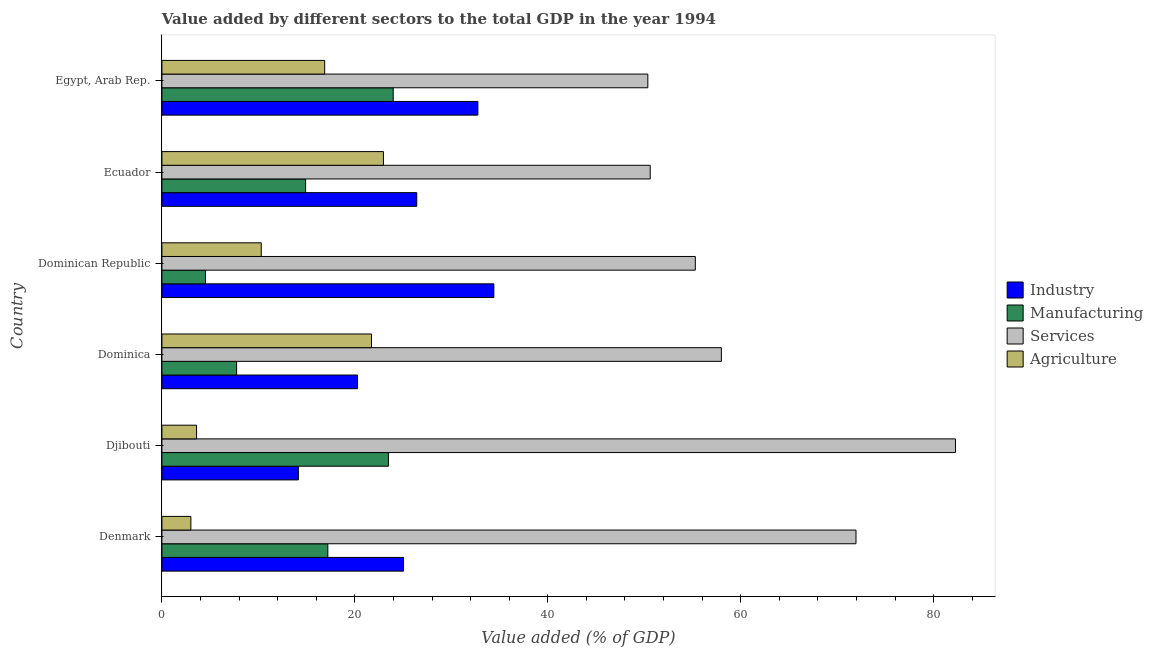How many different coloured bars are there?
Your response must be concise. 4. How many bars are there on the 2nd tick from the bottom?
Your answer should be very brief. 4. What is the label of the 2nd group of bars from the top?
Keep it short and to the point. Ecuador. What is the value added by manufacturing sector in Ecuador?
Your answer should be compact. 14.89. Across all countries, what is the maximum value added by industrial sector?
Keep it short and to the point. 34.41. Across all countries, what is the minimum value added by services sector?
Offer a terse response. 50.37. In which country was the value added by industrial sector maximum?
Give a very brief answer. Dominican Republic. In which country was the value added by services sector minimum?
Your response must be concise. Egypt, Arab Rep. What is the total value added by manufacturing sector in the graph?
Offer a very short reply. 91.81. What is the difference between the value added by services sector in Dominica and that in Ecuador?
Your answer should be very brief. 7.38. What is the difference between the value added by industrial sector in Ecuador and the value added by agricultural sector in Egypt, Arab Rep.?
Ensure brevity in your answer.  9.54. What is the average value added by agricultural sector per country?
Your response must be concise. 13.08. What is the difference between the value added by agricultural sector and value added by industrial sector in Denmark?
Keep it short and to the point. -22.05. In how many countries, is the value added by agricultural sector greater than 32 %?
Offer a very short reply. 0. What is the ratio of the value added by industrial sector in Ecuador to that in Egypt, Arab Rep.?
Offer a very short reply. 0.81. Is the value added by industrial sector in Djibouti less than that in Egypt, Arab Rep.?
Make the answer very short. Yes. Is the difference between the value added by industrial sector in Denmark and Djibouti greater than the difference between the value added by agricultural sector in Denmark and Djibouti?
Your answer should be very brief. Yes. What is the difference between the highest and the second highest value added by industrial sector?
Provide a short and direct response. 1.66. What is the difference between the highest and the lowest value added by services sector?
Offer a very short reply. 31.89. In how many countries, is the value added by services sector greater than the average value added by services sector taken over all countries?
Your answer should be very brief. 2. What does the 3rd bar from the top in Djibouti represents?
Provide a short and direct response. Manufacturing. What does the 2nd bar from the bottom in Denmark represents?
Your answer should be compact. Manufacturing. How many bars are there?
Offer a very short reply. 24. Are all the bars in the graph horizontal?
Offer a terse response. Yes. How many countries are there in the graph?
Give a very brief answer. 6. Are the values on the major ticks of X-axis written in scientific E-notation?
Make the answer very short. No. Does the graph contain grids?
Offer a very short reply. No. Where does the legend appear in the graph?
Offer a terse response. Center right. What is the title of the graph?
Offer a terse response. Value added by different sectors to the total GDP in the year 1994. Does "Other Minerals" appear as one of the legend labels in the graph?
Keep it short and to the point. No. What is the label or title of the X-axis?
Ensure brevity in your answer.  Value added (% of GDP). What is the label or title of the Y-axis?
Provide a succinct answer. Country. What is the Value added (% of GDP) in Industry in Denmark?
Your answer should be compact. 25.05. What is the Value added (% of GDP) in Manufacturing in Denmark?
Offer a very short reply. 17.2. What is the Value added (% of GDP) in Services in Denmark?
Offer a terse response. 71.95. What is the Value added (% of GDP) in Agriculture in Denmark?
Provide a succinct answer. 3. What is the Value added (% of GDP) in Industry in Djibouti?
Keep it short and to the point. 14.15. What is the Value added (% of GDP) of Manufacturing in Djibouti?
Offer a terse response. 23.48. What is the Value added (% of GDP) in Services in Djibouti?
Provide a succinct answer. 82.26. What is the Value added (% of GDP) of Agriculture in Djibouti?
Your response must be concise. 3.59. What is the Value added (% of GDP) in Industry in Dominica?
Your answer should be very brief. 20.28. What is the Value added (% of GDP) in Manufacturing in Dominica?
Offer a terse response. 7.74. What is the Value added (% of GDP) in Services in Dominica?
Ensure brevity in your answer.  57.99. What is the Value added (% of GDP) in Agriculture in Dominica?
Make the answer very short. 21.73. What is the Value added (% of GDP) of Industry in Dominican Republic?
Ensure brevity in your answer.  34.41. What is the Value added (% of GDP) in Manufacturing in Dominican Republic?
Your response must be concise. 4.51. What is the Value added (% of GDP) of Services in Dominican Republic?
Provide a succinct answer. 55.29. What is the Value added (% of GDP) in Agriculture in Dominican Republic?
Make the answer very short. 10.3. What is the Value added (% of GDP) in Industry in Ecuador?
Make the answer very short. 26.42. What is the Value added (% of GDP) of Manufacturing in Ecuador?
Your answer should be compact. 14.89. What is the Value added (% of GDP) of Services in Ecuador?
Your answer should be very brief. 50.62. What is the Value added (% of GDP) of Agriculture in Ecuador?
Offer a very short reply. 22.97. What is the Value added (% of GDP) in Industry in Egypt, Arab Rep.?
Give a very brief answer. 32.76. What is the Value added (% of GDP) of Manufacturing in Egypt, Arab Rep.?
Make the answer very short. 23.98. What is the Value added (% of GDP) of Services in Egypt, Arab Rep.?
Offer a terse response. 50.37. What is the Value added (% of GDP) in Agriculture in Egypt, Arab Rep.?
Offer a very short reply. 16.87. Across all countries, what is the maximum Value added (% of GDP) in Industry?
Make the answer very short. 34.41. Across all countries, what is the maximum Value added (% of GDP) in Manufacturing?
Offer a very short reply. 23.98. Across all countries, what is the maximum Value added (% of GDP) of Services?
Provide a succinct answer. 82.26. Across all countries, what is the maximum Value added (% of GDP) in Agriculture?
Keep it short and to the point. 22.97. Across all countries, what is the minimum Value added (% of GDP) in Industry?
Provide a short and direct response. 14.15. Across all countries, what is the minimum Value added (% of GDP) of Manufacturing?
Make the answer very short. 4.51. Across all countries, what is the minimum Value added (% of GDP) of Services?
Your response must be concise. 50.37. Across all countries, what is the minimum Value added (% of GDP) in Agriculture?
Provide a short and direct response. 3. What is the total Value added (% of GDP) in Industry in the graph?
Keep it short and to the point. 153.06. What is the total Value added (% of GDP) of Manufacturing in the graph?
Offer a terse response. 91.81. What is the total Value added (% of GDP) of Services in the graph?
Your response must be concise. 368.48. What is the total Value added (% of GDP) in Agriculture in the graph?
Make the answer very short. 78.46. What is the difference between the Value added (% of GDP) in Industry in Denmark and that in Djibouti?
Provide a short and direct response. 10.9. What is the difference between the Value added (% of GDP) in Manufacturing in Denmark and that in Djibouti?
Provide a short and direct response. -6.28. What is the difference between the Value added (% of GDP) in Services in Denmark and that in Djibouti?
Provide a short and direct response. -10.31. What is the difference between the Value added (% of GDP) of Agriculture in Denmark and that in Djibouti?
Your answer should be very brief. -0.59. What is the difference between the Value added (% of GDP) of Industry in Denmark and that in Dominica?
Give a very brief answer. 4.77. What is the difference between the Value added (% of GDP) in Manufacturing in Denmark and that in Dominica?
Your answer should be very brief. 9.46. What is the difference between the Value added (% of GDP) of Services in Denmark and that in Dominica?
Provide a short and direct response. 13.96. What is the difference between the Value added (% of GDP) in Agriculture in Denmark and that in Dominica?
Your response must be concise. -18.72. What is the difference between the Value added (% of GDP) in Industry in Denmark and that in Dominican Republic?
Offer a very short reply. -9.36. What is the difference between the Value added (% of GDP) of Manufacturing in Denmark and that in Dominican Republic?
Offer a very short reply. 12.69. What is the difference between the Value added (% of GDP) in Services in Denmark and that in Dominican Republic?
Provide a short and direct response. 16.66. What is the difference between the Value added (% of GDP) of Agriculture in Denmark and that in Dominican Republic?
Offer a terse response. -7.29. What is the difference between the Value added (% of GDP) in Industry in Denmark and that in Ecuador?
Ensure brevity in your answer.  -1.37. What is the difference between the Value added (% of GDP) of Manufacturing in Denmark and that in Ecuador?
Ensure brevity in your answer.  2.31. What is the difference between the Value added (% of GDP) in Services in Denmark and that in Ecuador?
Make the answer very short. 21.33. What is the difference between the Value added (% of GDP) of Agriculture in Denmark and that in Ecuador?
Your answer should be very brief. -19.96. What is the difference between the Value added (% of GDP) in Industry in Denmark and that in Egypt, Arab Rep.?
Your answer should be compact. -7.71. What is the difference between the Value added (% of GDP) in Manufacturing in Denmark and that in Egypt, Arab Rep.?
Offer a very short reply. -6.78. What is the difference between the Value added (% of GDP) of Services in Denmark and that in Egypt, Arab Rep.?
Offer a very short reply. 21.58. What is the difference between the Value added (% of GDP) in Agriculture in Denmark and that in Egypt, Arab Rep.?
Provide a short and direct response. -13.87. What is the difference between the Value added (% of GDP) of Industry in Djibouti and that in Dominica?
Ensure brevity in your answer.  -6.13. What is the difference between the Value added (% of GDP) of Manufacturing in Djibouti and that in Dominica?
Give a very brief answer. 15.74. What is the difference between the Value added (% of GDP) of Services in Djibouti and that in Dominica?
Your answer should be compact. 24.27. What is the difference between the Value added (% of GDP) in Agriculture in Djibouti and that in Dominica?
Make the answer very short. -18.13. What is the difference between the Value added (% of GDP) of Industry in Djibouti and that in Dominican Republic?
Offer a terse response. -20.26. What is the difference between the Value added (% of GDP) of Manufacturing in Djibouti and that in Dominican Republic?
Make the answer very short. 18.97. What is the difference between the Value added (% of GDP) of Services in Djibouti and that in Dominican Republic?
Provide a succinct answer. 26.97. What is the difference between the Value added (% of GDP) of Agriculture in Djibouti and that in Dominican Republic?
Provide a short and direct response. -6.7. What is the difference between the Value added (% of GDP) in Industry in Djibouti and that in Ecuador?
Provide a short and direct response. -12.27. What is the difference between the Value added (% of GDP) in Manufacturing in Djibouti and that in Ecuador?
Ensure brevity in your answer.  8.59. What is the difference between the Value added (% of GDP) of Services in Djibouti and that in Ecuador?
Provide a succinct answer. 31.64. What is the difference between the Value added (% of GDP) in Agriculture in Djibouti and that in Ecuador?
Your answer should be very brief. -19.37. What is the difference between the Value added (% of GDP) in Industry in Djibouti and that in Egypt, Arab Rep.?
Your answer should be very brief. -18.61. What is the difference between the Value added (% of GDP) of Manufacturing in Djibouti and that in Egypt, Arab Rep.?
Make the answer very short. -0.5. What is the difference between the Value added (% of GDP) in Services in Djibouti and that in Egypt, Arab Rep.?
Ensure brevity in your answer.  31.89. What is the difference between the Value added (% of GDP) of Agriculture in Djibouti and that in Egypt, Arab Rep.?
Provide a succinct answer. -13.28. What is the difference between the Value added (% of GDP) of Industry in Dominica and that in Dominican Republic?
Give a very brief answer. -14.13. What is the difference between the Value added (% of GDP) in Manufacturing in Dominica and that in Dominican Republic?
Provide a short and direct response. 3.23. What is the difference between the Value added (% of GDP) in Services in Dominica and that in Dominican Republic?
Make the answer very short. 2.7. What is the difference between the Value added (% of GDP) of Agriculture in Dominica and that in Dominican Republic?
Give a very brief answer. 11.43. What is the difference between the Value added (% of GDP) in Industry in Dominica and that in Ecuador?
Make the answer very short. -6.14. What is the difference between the Value added (% of GDP) of Manufacturing in Dominica and that in Ecuador?
Offer a terse response. -7.15. What is the difference between the Value added (% of GDP) in Services in Dominica and that in Ecuador?
Your response must be concise. 7.38. What is the difference between the Value added (% of GDP) of Agriculture in Dominica and that in Ecuador?
Offer a very short reply. -1.24. What is the difference between the Value added (% of GDP) in Industry in Dominica and that in Egypt, Arab Rep.?
Offer a terse response. -12.47. What is the difference between the Value added (% of GDP) of Manufacturing in Dominica and that in Egypt, Arab Rep.?
Your answer should be very brief. -16.23. What is the difference between the Value added (% of GDP) in Services in Dominica and that in Egypt, Arab Rep.?
Provide a succinct answer. 7.62. What is the difference between the Value added (% of GDP) of Agriculture in Dominica and that in Egypt, Arab Rep.?
Your response must be concise. 4.85. What is the difference between the Value added (% of GDP) in Industry in Dominican Republic and that in Ecuador?
Make the answer very short. 7.99. What is the difference between the Value added (% of GDP) in Manufacturing in Dominican Republic and that in Ecuador?
Give a very brief answer. -10.38. What is the difference between the Value added (% of GDP) in Services in Dominican Republic and that in Ecuador?
Offer a terse response. 4.68. What is the difference between the Value added (% of GDP) in Agriculture in Dominican Republic and that in Ecuador?
Offer a very short reply. -12.67. What is the difference between the Value added (% of GDP) of Industry in Dominican Republic and that in Egypt, Arab Rep.?
Give a very brief answer. 1.66. What is the difference between the Value added (% of GDP) in Manufacturing in Dominican Republic and that in Egypt, Arab Rep.?
Ensure brevity in your answer.  -19.46. What is the difference between the Value added (% of GDP) in Services in Dominican Republic and that in Egypt, Arab Rep.?
Provide a short and direct response. 4.92. What is the difference between the Value added (% of GDP) in Agriculture in Dominican Republic and that in Egypt, Arab Rep.?
Your answer should be very brief. -6.58. What is the difference between the Value added (% of GDP) in Industry in Ecuador and that in Egypt, Arab Rep.?
Provide a succinct answer. -6.34. What is the difference between the Value added (% of GDP) in Manufacturing in Ecuador and that in Egypt, Arab Rep.?
Your answer should be compact. -9.08. What is the difference between the Value added (% of GDP) of Services in Ecuador and that in Egypt, Arab Rep.?
Offer a very short reply. 0.25. What is the difference between the Value added (% of GDP) in Agriculture in Ecuador and that in Egypt, Arab Rep.?
Give a very brief answer. 6.09. What is the difference between the Value added (% of GDP) of Industry in Denmark and the Value added (% of GDP) of Manufacturing in Djibouti?
Provide a succinct answer. 1.57. What is the difference between the Value added (% of GDP) in Industry in Denmark and the Value added (% of GDP) in Services in Djibouti?
Give a very brief answer. -57.21. What is the difference between the Value added (% of GDP) in Industry in Denmark and the Value added (% of GDP) in Agriculture in Djibouti?
Keep it short and to the point. 21.45. What is the difference between the Value added (% of GDP) of Manufacturing in Denmark and the Value added (% of GDP) of Services in Djibouti?
Offer a very short reply. -65.06. What is the difference between the Value added (% of GDP) in Manufacturing in Denmark and the Value added (% of GDP) in Agriculture in Djibouti?
Your answer should be compact. 13.61. What is the difference between the Value added (% of GDP) in Services in Denmark and the Value added (% of GDP) in Agriculture in Djibouti?
Provide a short and direct response. 68.35. What is the difference between the Value added (% of GDP) of Industry in Denmark and the Value added (% of GDP) of Manufacturing in Dominica?
Provide a succinct answer. 17.3. What is the difference between the Value added (% of GDP) of Industry in Denmark and the Value added (% of GDP) of Services in Dominica?
Keep it short and to the point. -32.94. What is the difference between the Value added (% of GDP) of Industry in Denmark and the Value added (% of GDP) of Agriculture in Dominica?
Offer a terse response. 3.32. What is the difference between the Value added (% of GDP) of Manufacturing in Denmark and the Value added (% of GDP) of Services in Dominica?
Ensure brevity in your answer.  -40.79. What is the difference between the Value added (% of GDP) of Manufacturing in Denmark and the Value added (% of GDP) of Agriculture in Dominica?
Provide a short and direct response. -4.53. What is the difference between the Value added (% of GDP) in Services in Denmark and the Value added (% of GDP) in Agriculture in Dominica?
Provide a succinct answer. 50.22. What is the difference between the Value added (% of GDP) of Industry in Denmark and the Value added (% of GDP) of Manufacturing in Dominican Republic?
Provide a short and direct response. 20.53. What is the difference between the Value added (% of GDP) in Industry in Denmark and the Value added (% of GDP) in Services in Dominican Republic?
Keep it short and to the point. -30.24. What is the difference between the Value added (% of GDP) in Industry in Denmark and the Value added (% of GDP) in Agriculture in Dominican Republic?
Your response must be concise. 14.75. What is the difference between the Value added (% of GDP) of Manufacturing in Denmark and the Value added (% of GDP) of Services in Dominican Republic?
Make the answer very short. -38.09. What is the difference between the Value added (% of GDP) in Manufacturing in Denmark and the Value added (% of GDP) in Agriculture in Dominican Republic?
Provide a succinct answer. 6.9. What is the difference between the Value added (% of GDP) in Services in Denmark and the Value added (% of GDP) in Agriculture in Dominican Republic?
Provide a succinct answer. 61.65. What is the difference between the Value added (% of GDP) in Industry in Denmark and the Value added (% of GDP) in Manufacturing in Ecuador?
Provide a succinct answer. 10.15. What is the difference between the Value added (% of GDP) in Industry in Denmark and the Value added (% of GDP) in Services in Ecuador?
Keep it short and to the point. -25.57. What is the difference between the Value added (% of GDP) of Industry in Denmark and the Value added (% of GDP) of Agriculture in Ecuador?
Offer a terse response. 2.08. What is the difference between the Value added (% of GDP) in Manufacturing in Denmark and the Value added (% of GDP) in Services in Ecuador?
Your answer should be very brief. -33.42. What is the difference between the Value added (% of GDP) in Manufacturing in Denmark and the Value added (% of GDP) in Agriculture in Ecuador?
Your response must be concise. -5.77. What is the difference between the Value added (% of GDP) of Services in Denmark and the Value added (% of GDP) of Agriculture in Ecuador?
Give a very brief answer. 48.98. What is the difference between the Value added (% of GDP) of Industry in Denmark and the Value added (% of GDP) of Manufacturing in Egypt, Arab Rep.?
Your answer should be very brief. 1.07. What is the difference between the Value added (% of GDP) in Industry in Denmark and the Value added (% of GDP) in Services in Egypt, Arab Rep.?
Ensure brevity in your answer.  -25.32. What is the difference between the Value added (% of GDP) in Industry in Denmark and the Value added (% of GDP) in Agriculture in Egypt, Arab Rep.?
Keep it short and to the point. 8.17. What is the difference between the Value added (% of GDP) of Manufacturing in Denmark and the Value added (% of GDP) of Services in Egypt, Arab Rep.?
Ensure brevity in your answer.  -33.17. What is the difference between the Value added (% of GDP) of Manufacturing in Denmark and the Value added (% of GDP) of Agriculture in Egypt, Arab Rep.?
Your answer should be very brief. 0.33. What is the difference between the Value added (% of GDP) of Services in Denmark and the Value added (% of GDP) of Agriculture in Egypt, Arab Rep.?
Offer a very short reply. 55.07. What is the difference between the Value added (% of GDP) of Industry in Djibouti and the Value added (% of GDP) of Manufacturing in Dominica?
Provide a succinct answer. 6.4. What is the difference between the Value added (% of GDP) in Industry in Djibouti and the Value added (% of GDP) in Services in Dominica?
Provide a succinct answer. -43.85. What is the difference between the Value added (% of GDP) of Industry in Djibouti and the Value added (% of GDP) of Agriculture in Dominica?
Provide a succinct answer. -7.58. What is the difference between the Value added (% of GDP) of Manufacturing in Djibouti and the Value added (% of GDP) of Services in Dominica?
Give a very brief answer. -34.51. What is the difference between the Value added (% of GDP) in Manufacturing in Djibouti and the Value added (% of GDP) in Agriculture in Dominica?
Ensure brevity in your answer.  1.75. What is the difference between the Value added (% of GDP) of Services in Djibouti and the Value added (% of GDP) of Agriculture in Dominica?
Offer a very short reply. 60.53. What is the difference between the Value added (% of GDP) in Industry in Djibouti and the Value added (% of GDP) in Manufacturing in Dominican Republic?
Offer a terse response. 9.63. What is the difference between the Value added (% of GDP) of Industry in Djibouti and the Value added (% of GDP) of Services in Dominican Republic?
Give a very brief answer. -41.15. What is the difference between the Value added (% of GDP) in Industry in Djibouti and the Value added (% of GDP) in Agriculture in Dominican Republic?
Your answer should be compact. 3.85. What is the difference between the Value added (% of GDP) of Manufacturing in Djibouti and the Value added (% of GDP) of Services in Dominican Republic?
Give a very brief answer. -31.81. What is the difference between the Value added (% of GDP) in Manufacturing in Djibouti and the Value added (% of GDP) in Agriculture in Dominican Republic?
Your response must be concise. 13.18. What is the difference between the Value added (% of GDP) in Services in Djibouti and the Value added (% of GDP) in Agriculture in Dominican Republic?
Keep it short and to the point. 71.96. What is the difference between the Value added (% of GDP) in Industry in Djibouti and the Value added (% of GDP) in Manufacturing in Ecuador?
Provide a succinct answer. -0.75. What is the difference between the Value added (% of GDP) of Industry in Djibouti and the Value added (% of GDP) of Services in Ecuador?
Provide a short and direct response. -36.47. What is the difference between the Value added (% of GDP) in Industry in Djibouti and the Value added (% of GDP) in Agriculture in Ecuador?
Your response must be concise. -8.82. What is the difference between the Value added (% of GDP) of Manufacturing in Djibouti and the Value added (% of GDP) of Services in Ecuador?
Provide a short and direct response. -27.14. What is the difference between the Value added (% of GDP) of Manufacturing in Djibouti and the Value added (% of GDP) of Agriculture in Ecuador?
Keep it short and to the point. 0.51. What is the difference between the Value added (% of GDP) of Services in Djibouti and the Value added (% of GDP) of Agriculture in Ecuador?
Ensure brevity in your answer.  59.29. What is the difference between the Value added (% of GDP) in Industry in Djibouti and the Value added (% of GDP) in Manufacturing in Egypt, Arab Rep.?
Your response must be concise. -9.83. What is the difference between the Value added (% of GDP) in Industry in Djibouti and the Value added (% of GDP) in Services in Egypt, Arab Rep.?
Your response must be concise. -36.22. What is the difference between the Value added (% of GDP) in Industry in Djibouti and the Value added (% of GDP) in Agriculture in Egypt, Arab Rep.?
Provide a short and direct response. -2.73. What is the difference between the Value added (% of GDP) of Manufacturing in Djibouti and the Value added (% of GDP) of Services in Egypt, Arab Rep.?
Provide a short and direct response. -26.89. What is the difference between the Value added (% of GDP) in Manufacturing in Djibouti and the Value added (% of GDP) in Agriculture in Egypt, Arab Rep.?
Ensure brevity in your answer.  6.61. What is the difference between the Value added (% of GDP) of Services in Djibouti and the Value added (% of GDP) of Agriculture in Egypt, Arab Rep.?
Offer a very short reply. 65.39. What is the difference between the Value added (% of GDP) of Industry in Dominica and the Value added (% of GDP) of Manufacturing in Dominican Republic?
Keep it short and to the point. 15.77. What is the difference between the Value added (% of GDP) of Industry in Dominica and the Value added (% of GDP) of Services in Dominican Republic?
Offer a terse response. -35.01. What is the difference between the Value added (% of GDP) in Industry in Dominica and the Value added (% of GDP) in Agriculture in Dominican Republic?
Provide a short and direct response. 9.98. What is the difference between the Value added (% of GDP) of Manufacturing in Dominica and the Value added (% of GDP) of Services in Dominican Republic?
Your response must be concise. -47.55. What is the difference between the Value added (% of GDP) in Manufacturing in Dominica and the Value added (% of GDP) in Agriculture in Dominican Republic?
Provide a short and direct response. -2.55. What is the difference between the Value added (% of GDP) in Services in Dominica and the Value added (% of GDP) in Agriculture in Dominican Republic?
Give a very brief answer. 47.7. What is the difference between the Value added (% of GDP) in Industry in Dominica and the Value added (% of GDP) in Manufacturing in Ecuador?
Offer a very short reply. 5.39. What is the difference between the Value added (% of GDP) of Industry in Dominica and the Value added (% of GDP) of Services in Ecuador?
Provide a succinct answer. -30.33. What is the difference between the Value added (% of GDP) in Industry in Dominica and the Value added (% of GDP) in Agriculture in Ecuador?
Provide a short and direct response. -2.68. What is the difference between the Value added (% of GDP) of Manufacturing in Dominica and the Value added (% of GDP) of Services in Ecuador?
Offer a terse response. -42.87. What is the difference between the Value added (% of GDP) in Manufacturing in Dominica and the Value added (% of GDP) in Agriculture in Ecuador?
Your answer should be very brief. -15.22. What is the difference between the Value added (% of GDP) in Services in Dominica and the Value added (% of GDP) in Agriculture in Ecuador?
Keep it short and to the point. 35.03. What is the difference between the Value added (% of GDP) in Industry in Dominica and the Value added (% of GDP) in Manufacturing in Egypt, Arab Rep.?
Make the answer very short. -3.7. What is the difference between the Value added (% of GDP) of Industry in Dominica and the Value added (% of GDP) of Services in Egypt, Arab Rep.?
Keep it short and to the point. -30.09. What is the difference between the Value added (% of GDP) in Industry in Dominica and the Value added (% of GDP) in Agriculture in Egypt, Arab Rep.?
Offer a very short reply. 3.41. What is the difference between the Value added (% of GDP) of Manufacturing in Dominica and the Value added (% of GDP) of Services in Egypt, Arab Rep.?
Ensure brevity in your answer.  -42.63. What is the difference between the Value added (% of GDP) of Manufacturing in Dominica and the Value added (% of GDP) of Agriculture in Egypt, Arab Rep.?
Your answer should be compact. -9.13. What is the difference between the Value added (% of GDP) of Services in Dominica and the Value added (% of GDP) of Agriculture in Egypt, Arab Rep.?
Your answer should be compact. 41.12. What is the difference between the Value added (% of GDP) in Industry in Dominican Republic and the Value added (% of GDP) in Manufacturing in Ecuador?
Ensure brevity in your answer.  19.52. What is the difference between the Value added (% of GDP) in Industry in Dominican Republic and the Value added (% of GDP) in Services in Ecuador?
Provide a succinct answer. -16.21. What is the difference between the Value added (% of GDP) in Industry in Dominican Republic and the Value added (% of GDP) in Agriculture in Ecuador?
Provide a succinct answer. 11.44. What is the difference between the Value added (% of GDP) of Manufacturing in Dominican Republic and the Value added (% of GDP) of Services in Ecuador?
Offer a very short reply. -46.1. What is the difference between the Value added (% of GDP) of Manufacturing in Dominican Republic and the Value added (% of GDP) of Agriculture in Ecuador?
Your answer should be very brief. -18.45. What is the difference between the Value added (% of GDP) in Services in Dominican Republic and the Value added (% of GDP) in Agriculture in Ecuador?
Your answer should be compact. 32.33. What is the difference between the Value added (% of GDP) of Industry in Dominican Republic and the Value added (% of GDP) of Manufacturing in Egypt, Arab Rep.?
Your response must be concise. 10.43. What is the difference between the Value added (% of GDP) in Industry in Dominican Republic and the Value added (% of GDP) in Services in Egypt, Arab Rep.?
Provide a short and direct response. -15.96. What is the difference between the Value added (% of GDP) of Industry in Dominican Republic and the Value added (% of GDP) of Agriculture in Egypt, Arab Rep.?
Offer a terse response. 17.54. What is the difference between the Value added (% of GDP) of Manufacturing in Dominican Republic and the Value added (% of GDP) of Services in Egypt, Arab Rep.?
Your answer should be compact. -45.86. What is the difference between the Value added (% of GDP) in Manufacturing in Dominican Republic and the Value added (% of GDP) in Agriculture in Egypt, Arab Rep.?
Your answer should be very brief. -12.36. What is the difference between the Value added (% of GDP) in Services in Dominican Republic and the Value added (% of GDP) in Agriculture in Egypt, Arab Rep.?
Offer a terse response. 38.42. What is the difference between the Value added (% of GDP) of Industry in Ecuador and the Value added (% of GDP) of Manufacturing in Egypt, Arab Rep.?
Your answer should be compact. 2.44. What is the difference between the Value added (% of GDP) of Industry in Ecuador and the Value added (% of GDP) of Services in Egypt, Arab Rep.?
Ensure brevity in your answer.  -23.95. What is the difference between the Value added (% of GDP) in Industry in Ecuador and the Value added (% of GDP) in Agriculture in Egypt, Arab Rep.?
Your response must be concise. 9.54. What is the difference between the Value added (% of GDP) in Manufacturing in Ecuador and the Value added (% of GDP) in Services in Egypt, Arab Rep.?
Ensure brevity in your answer.  -35.48. What is the difference between the Value added (% of GDP) of Manufacturing in Ecuador and the Value added (% of GDP) of Agriculture in Egypt, Arab Rep.?
Give a very brief answer. -1.98. What is the difference between the Value added (% of GDP) of Services in Ecuador and the Value added (% of GDP) of Agriculture in Egypt, Arab Rep.?
Offer a terse response. 33.74. What is the average Value added (% of GDP) of Industry per country?
Offer a very short reply. 25.51. What is the average Value added (% of GDP) in Manufacturing per country?
Offer a terse response. 15.3. What is the average Value added (% of GDP) in Services per country?
Make the answer very short. 61.41. What is the average Value added (% of GDP) in Agriculture per country?
Ensure brevity in your answer.  13.08. What is the difference between the Value added (% of GDP) of Industry and Value added (% of GDP) of Manufacturing in Denmark?
Offer a very short reply. 7.85. What is the difference between the Value added (% of GDP) in Industry and Value added (% of GDP) in Services in Denmark?
Your answer should be very brief. -46.9. What is the difference between the Value added (% of GDP) in Industry and Value added (% of GDP) in Agriculture in Denmark?
Give a very brief answer. 22.05. What is the difference between the Value added (% of GDP) in Manufacturing and Value added (% of GDP) in Services in Denmark?
Offer a very short reply. -54.75. What is the difference between the Value added (% of GDP) of Manufacturing and Value added (% of GDP) of Agriculture in Denmark?
Provide a succinct answer. 14.2. What is the difference between the Value added (% of GDP) in Services and Value added (% of GDP) in Agriculture in Denmark?
Give a very brief answer. 68.95. What is the difference between the Value added (% of GDP) in Industry and Value added (% of GDP) in Manufacturing in Djibouti?
Keep it short and to the point. -9.33. What is the difference between the Value added (% of GDP) in Industry and Value added (% of GDP) in Services in Djibouti?
Ensure brevity in your answer.  -68.11. What is the difference between the Value added (% of GDP) of Industry and Value added (% of GDP) of Agriculture in Djibouti?
Ensure brevity in your answer.  10.55. What is the difference between the Value added (% of GDP) of Manufacturing and Value added (% of GDP) of Services in Djibouti?
Your answer should be very brief. -58.78. What is the difference between the Value added (% of GDP) of Manufacturing and Value added (% of GDP) of Agriculture in Djibouti?
Your response must be concise. 19.89. What is the difference between the Value added (% of GDP) in Services and Value added (% of GDP) in Agriculture in Djibouti?
Provide a succinct answer. 78.67. What is the difference between the Value added (% of GDP) of Industry and Value added (% of GDP) of Manufacturing in Dominica?
Keep it short and to the point. 12.54. What is the difference between the Value added (% of GDP) in Industry and Value added (% of GDP) in Services in Dominica?
Make the answer very short. -37.71. What is the difference between the Value added (% of GDP) in Industry and Value added (% of GDP) in Agriculture in Dominica?
Give a very brief answer. -1.45. What is the difference between the Value added (% of GDP) of Manufacturing and Value added (% of GDP) of Services in Dominica?
Make the answer very short. -50.25. What is the difference between the Value added (% of GDP) of Manufacturing and Value added (% of GDP) of Agriculture in Dominica?
Offer a very short reply. -13.98. What is the difference between the Value added (% of GDP) of Services and Value added (% of GDP) of Agriculture in Dominica?
Make the answer very short. 36.27. What is the difference between the Value added (% of GDP) in Industry and Value added (% of GDP) in Manufacturing in Dominican Republic?
Give a very brief answer. 29.9. What is the difference between the Value added (% of GDP) of Industry and Value added (% of GDP) of Services in Dominican Republic?
Give a very brief answer. -20.88. What is the difference between the Value added (% of GDP) in Industry and Value added (% of GDP) in Agriculture in Dominican Republic?
Provide a succinct answer. 24.11. What is the difference between the Value added (% of GDP) in Manufacturing and Value added (% of GDP) in Services in Dominican Republic?
Your answer should be very brief. -50.78. What is the difference between the Value added (% of GDP) of Manufacturing and Value added (% of GDP) of Agriculture in Dominican Republic?
Make the answer very short. -5.78. What is the difference between the Value added (% of GDP) in Services and Value added (% of GDP) in Agriculture in Dominican Republic?
Offer a terse response. 44.99. What is the difference between the Value added (% of GDP) of Industry and Value added (% of GDP) of Manufacturing in Ecuador?
Your answer should be compact. 11.52. What is the difference between the Value added (% of GDP) of Industry and Value added (% of GDP) of Services in Ecuador?
Provide a short and direct response. -24.2. What is the difference between the Value added (% of GDP) of Industry and Value added (% of GDP) of Agriculture in Ecuador?
Your answer should be very brief. 3.45. What is the difference between the Value added (% of GDP) in Manufacturing and Value added (% of GDP) in Services in Ecuador?
Keep it short and to the point. -35.72. What is the difference between the Value added (% of GDP) of Manufacturing and Value added (% of GDP) of Agriculture in Ecuador?
Provide a succinct answer. -8.07. What is the difference between the Value added (% of GDP) of Services and Value added (% of GDP) of Agriculture in Ecuador?
Your response must be concise. 27.65. What is the difference between the Value added (% of GDP) in Industry and Value added (% of GDP) in Manufacturing in Egypt, Arab Rep.?
Ensure brevity in your answer.  8.78. What is the difference between the Value added (% of GDP) of Industry and Value added (% of GDP) of Services in Egypt, Arab Rep.?
Provide a short and direct response. -17.62. What is the difference between the Value added (% of GDP) in Industry and Value added (% of GDP) in Agriculture in Egypt, Arab Rep.?
Give a very brief answer. 15.88. What is the difference between the Value added (% of GDP) in Manufacturing and Value added (% of GDP) in Services in Egypt, Arab Rep.?
Your answer should be compact. -26.39. What is the difference between the Value added (% of GDP) in Manufacturing and Value added (% of GDP) in Agriculture in Egypt, Arab Rep.?
Give a very brief answer. 7.1. What is the difference between the Value added (% of GDP) of Services and Value added (% of GDP) of Agriculture in Egypt, Arab Rep.?
Keep it short and to the point. 33.5. What is the ratio of the Value added (% of GDP) of Industry in Denmark to that in Djibouti?
Give a very brief answer. 1.77. What is the ratio of the Value added (% of GDP) in Manufacturing in Denmark to that in Djibouti?
Offer a very short reply. 0.73. What is the ratio of the Value added (% of GDP) in Services in Denmark to that in Djibouti?
Make the answer very short. 0.87. What is the ratio of the Value added (% of GDP) of Agriculture in Denmark to that in Djibouti?
Provide a succinct answer. 0.84. What is the ratio of the Value added (% of GDP) of Industry in Denmark to that in Dominica?
Your answer should be very brief. 1.24. What is the ratio of the Value added (% of GDP) of Manufacturing in Denmark to that in Dominica?
Provide a succinct answer. 2.22. What is the ratio of the Value added (% of GDP) of Services in Denmark to that in Dominica?
Offer a very short reply. 1.24. What is the ratio of the Value added (% of GDP) of Agriculture in Denmark to that in Dominica?
Provide a short and direct response. 0.14. What is the ratio of the Value added (% of GDP) of Industry in Denmark to that in Dominican Republic?
Your answer should be compact. 0.73. What is the ratio of the Value added (% of GDP) in Manufacturing in Denmark to that in Dominican Republic?
Give a very brief answer. 3.81. What is the ratio of the Value added (% of GDP) in Services in Denmark to that in Dominican Republic?
Keep it short and to the point. 1.3. What is the ratio of the Value added (% of GDP) in Agriculture in Denmark to that in Dominican Republic?
Make the answer very short. 0.29. What is the ratio of the Value added (% of GDP) in Industry in Denmark to that in Ecuador?
Your answer should be compact. 0.95. What is the ratio of the Value added (% of GDP) of Manufacturing in Denmark to that in Ecuador?
Keep it short and to the point. 1.15. What is the ratio of the Value added (% of GDP) of Services in Denmark to that in Ecuador?
Provide a succinct answer. 1.42. What is the ratio of the Value added (% of GDP) in Agriculture in Denmark to that in Ecuador?
Your answer should be very brief. 0.13. What is the ratio of the Value added (% of GDP) of Industry in Denmark to that in Egypt, Arab Rep.?
Your response must be concise. 0.76. What is the ratio of the Value added (% of GDP) in Manufacturing in Denmark to that in Egypt, Arab Rep.?
Your answer should be compact. 0.72. What is the ratio of the Value added (% of GDP) in Services in Denmark to that in Egypt, Arab Rep.?
Ensure brevity in your answer.  1.43. What is the ratio of the Value added (% of GDP) in Agriculture in Denmark to that in Egypt, Arab Rep.?
Offer a terse response. 0.18. What is the ratio of the Value added (% of GDP) of Industry in Djibouti to that in Dominica?
Keep it short and to the point. 0.7. What is the ratio of the Value added (% of GDP) in Manufacturing in Djibouti to that in Dominica?
Make the answer very short. 3.03. What is the ratio of the Value added (% of GDP) in Services in Djibouti to that in Dominica?
Your response must be concise. 1.42. What is the ratio of the Value added (% of GDP) of Agriculture in Djibouti to that in Dominica?
Your answer should be compact. 0.17. What is the ratio of the Value added (% of GDP) of Industry in Djibouti to that in Dominican Republic?
Make the answer very short. 0.41. What is the ratio of the Value added (% of GDP) of Manufacturing in Djibouti to that in Dominican Republic?
Your response must be concise. 5.2. What is the ratio of the Value added (% of GDP) in Services in Djibouti to that in Dominican Republic?
Provide a short and direct response. 1.49. What is the ratio of the Value added (% of GDP) in Agriculture in Djibouti to that in Dominican Republic?
Offer a terse response. 0.35. What is the ratio of the Value added (% of GDP) in Industry in Djibouti to that in Ecuador?
Keep it short and to the point. 0.54. What is the ratio of the Value added (% of GDP) of Manufacturing in Djibouti to that in Ecuador?
Ensure brevity in your answer.  1.58. What is the ratio of the Value added (% of GDP) in Services in Djibouti to that in Ecuador?
Offer a very short reply. 1.63. What is the ratio of the Value added (% of GDP) of Agriculture in Djibouti to that in Ecuador?
Your response must be concise. 0.16. What is the ratio of the Value added (% of GDP) in Industry in Djibouti to that in Egypt, Arab Rep.?
Your answer should be very brief. 0.43. What is the ratio of the Value added (% of GDP) of Manufacturing in Djibouti to that in Egypt, Arab Rep.?
Offer a very short reply. 0.98. What is the ratio of the Value added (% of GDP) of Services in Djibouti to that in Egypt, Arab Rep.?
Offer a very short reply. 1.63. What is the ratio of the Value added (% of GDP) of Agriculture in Djibouti to that in Egypt, Arab Rep.?
Make the answer very short. 0.21. What is the ratio of the Value added (% of GDP) in Industry in Dominica to that in Dominican Republic?
Your answer should be very brief. 0.59. What is the ratio of the Value added (% of GDP) of Manufacturing in Dominica to that in Dominican Republic?
Give a very brief answer. 1.72. What is the ratio of the Value added (% of GDP) of Services in Dominica to that in Dominican Republic?
Ensure brevity in your answer.  1.05. What is the ratio of the Value added (% of GDP) of Agriculture in Dominica to that in Dominican Republic?
Your answer should be compact. 2.11. What is the ratio of the Value added (% of GDP) of Industry in Dominica to that in Ecuador?
Provide a succinct answer. 0.77. What is the ratio of the Value added (% of GDP) in Manufacturing in Dominica to that in Ecuador?
Your answer should be compact. 0.52. What is the ratio of the Value added (% of GDP) in Services in Dominica to that in Ecuador?
Your response must be concise. 1.15. What is the ratio of the Value added (% of GDP) in Agriculture in Dominica to that in Ecuador?
Give a very brief answer. 0.95. What is the ratio of the Value added (% of GDP) in Industry in Dominica to that in Egypt, Arab Rep.?
Offer a terse response. 0.62. What is the ratio of the Value added (% of GDP) in Manufacturing in Dominica to that in Egypt, Arab Rep.?
Give a very brief answer. 0.32. What is the ratio of the Value added (% of GDP) in Services in Dominica to that in Egypt, Arab Rep.?
Ensure brevity in your answer.  1.15. What is the ratio of the Value added (% of GDP) of Agriculture in Dominica to that in Egypt, Arab Rep.?
Your answer should be very brief. 1.29. What is the ratio of the Value added (% of GDP) of Industry in Dominican Republic to that in Ecuador?
Keep it short and to the point. 1.3. What is the ratio of the Value added (% of GDP) in Manufacturing in Dominican Republic to that in Ecuador?
Your answer should be very brief. 0.3. What is the ratio of the Value added (% of GDP) of Services in Dominican Republic to that in Ecuador?
Your answer should be very brief. 1.09. What is the ratio of the Value added (% of GDP) of Agriculture in Dominican Republic to that in Ecuador?
Offer a terse response. 0.45. What is the ratio of the Value added (% of GDP) of Industry in Dominican Republic to that in Egypt, Arab Rep.?
Ensure brevity in your answer.  1.05. What is the ratio of the Value added (% of GDP) in Manufacturing in Dominican Republic to that in Egypt, Arab Rep.?
Your response must be concise. 0.19. What is the ratio of the Value added (% of GDP) in Services in Dominican Republic to that in Egypt, Arab Rep.?
Keep it short and to the point. 1.1. What is the ratio of the Value added (% of GDP) in Agriculture in Dominican Republic to that in Egypt, Arab Rep.?
Offer a terse response. 0.61. What is the ratio of the Value added (% of GDP) in Industry in Ecuador to that in Egypt, Arab Rep.?
Provide a short and direct response. 0.81. What is the ratio of the Value added (% of GDP) of Manufacturing in Ecuador to that in Egypt, Arab Rep.?
Your answer should be compact. 0.62. What is the ratio of the Value added (% of GDP) in Services in Ecuador to that in Egypt, Arab Rep.?
Offer a terse response. 1. What is the ratio of the Value added (% of GDP) of Agriculture in Ecuador to that in Egypt, Arab Rep.?
Ensure brevity in your answer.  1.36. What is the difference between the highest and the second highest Value added (% of GDP) of Industry?
Make the answer very short. 1.66. What is the difference between the highest and the second highest Value added (% of GDP) in Manufacturing?
Offer a terse response. 0.5. What is the difference between the highest and the second highest Value added (% of GDP) of Services?
Your answer should be compact. 10.31. What is the difference between the highest and the second highest Value added (% of GDP) of Agriculture?
Provide a succinct answer. 1.24. What is the difference between the highest and the lowest Value added (% of GDP) of Industry?
Your response must be concise. 20.26. What is the difference between the highest and the lowest Value added (% of GDP) in Manufacturing?
Offer a very short reply. 19.46. What is the difference between the highest and the lowest Value added (% of GDP) in Services?
Give a very brief answer. 31.89. What is the difference between the highest and the lowest Value added (% of GDP) in Agriculture?
Provide a succinct answer. 19.96. 